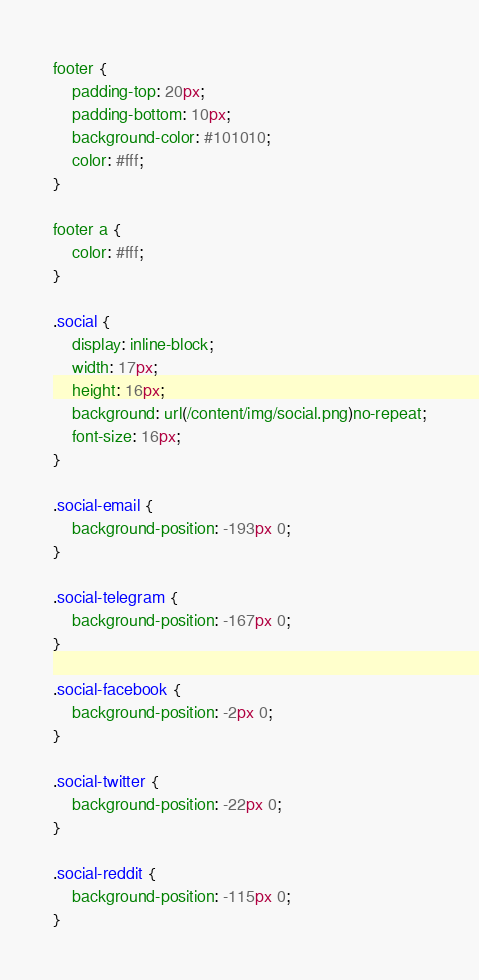Convert code to text. <code><loc_0><loc_0><loc_500><loc_500><_CSS_>footer {
    padding-top: 20px;
    padding-bottom: 10px;
    background-color: #101010;
    color: #fff;
}

footer a {
    color: #fff;
}

.social {
    display: inline-block;
    width: 17px;
    height: 16px;
    background: url(/content/img/social.png)no-repeat;
    font-size: 16px;
}

.social-email {
    background-position: -193px 0;
}

.social-telegram {
    background-position: -167px 0;
}

.social-facebook {
    background-position: -2px 0;
}

.social-twitter {
    background-position: -22px 0;
}

.social-reddit {
    background-position: -115px 0;
}
</code> 